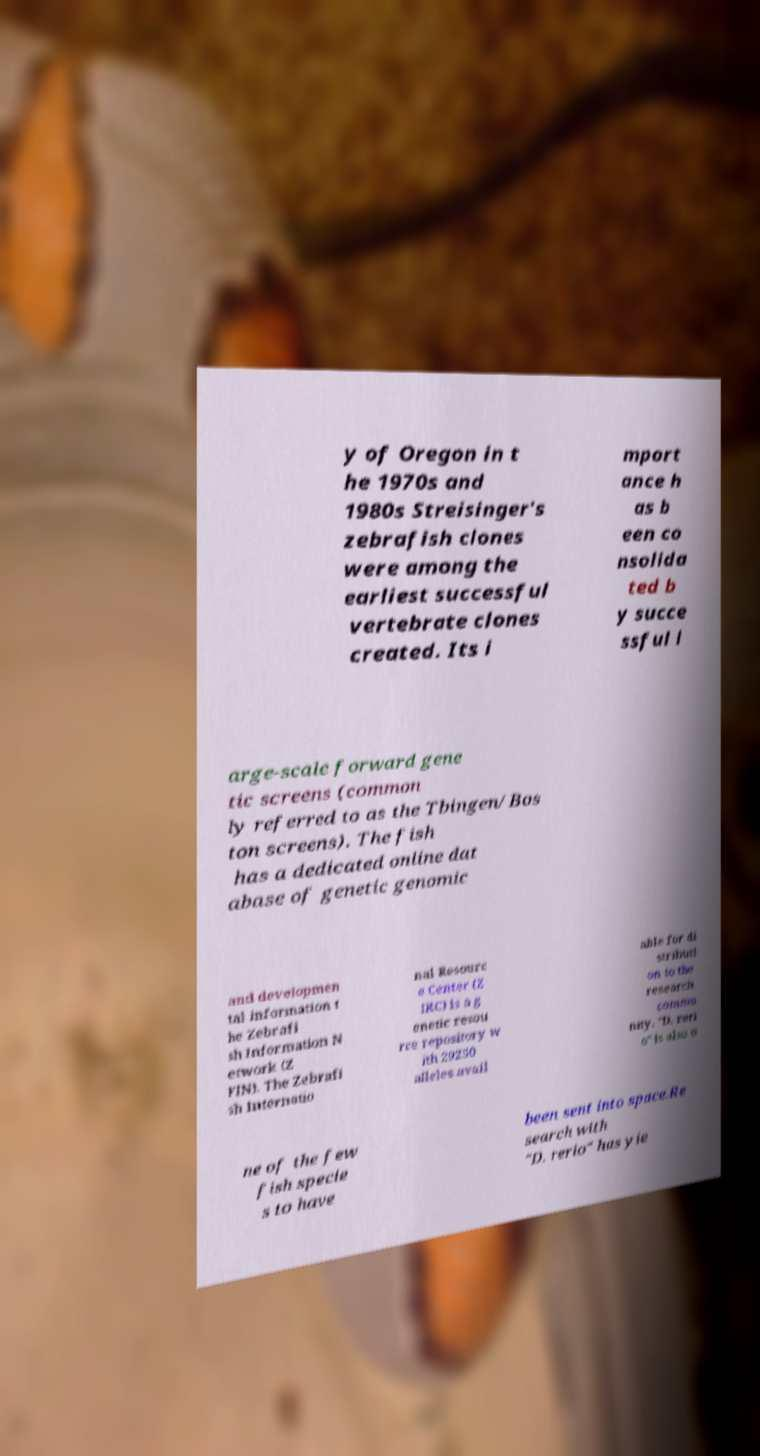Please read and relay the text visible in this image. What does it say? y of Oregon in t he 1970s and 1980s Streisinger's zebrafish clones were among the earliest successful vertebrate clones created. Its i mport ance h as b een co nsolida ted b y succe ssful l arge-scale forward gene tic screens (common ly referred to as the Tbingen/Bos ton screens). The fish has a dedicated online dat abase of genetic genomic and developmen tal information t he Zebrafi sh Information N etwork (Z FIN). The Zebrafi sh Internatio nal Resourc e Center (Z IRC) is a g enetic resou rce repository w ith 29250 alleles avail able for di stributi on to the research commu nity. "D. reri o" is also o ne of the few fish specie s to have been sent into space.Re search with "D. rerio" has yie 